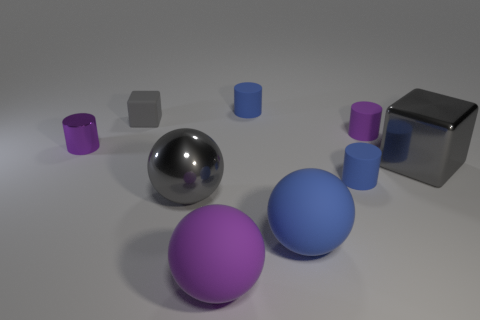Subtract all red cylinders. Subtract all cyan blocks. How many cylinders are left? 4 Add 1 red matte spheres. How many objects exist? 10 Subtract all blocks. How many objects are left? 7 Add 2 tiny purple cylinders. How many tiny purple cylinders are left? 4 Add 2 big gray matte cylinders. How many big gray matte cylinders exist? 2 Subtract 0 purple blocks. How many objects are left? 9 Subtract all cubes. Subtract all large spheres. How many objects are left? 4 